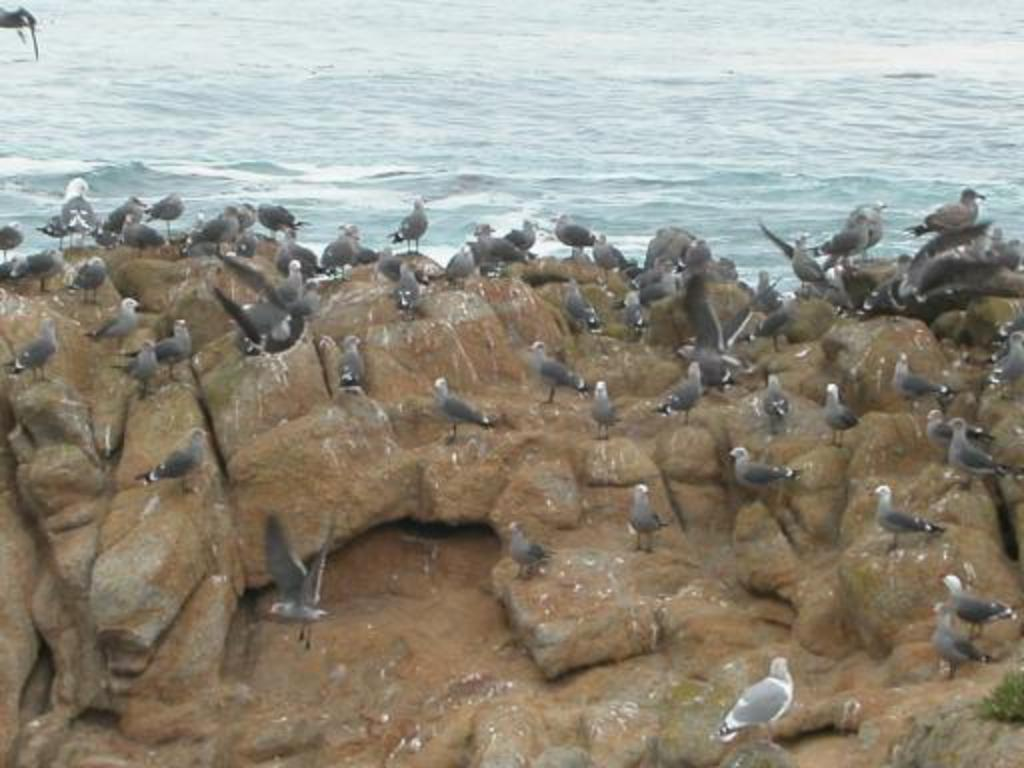What type of animals can be seen in the image? There are birds in the image. Where are the birds located? The birds are on a rock. What is the background of the image? The rock is in front of the sea. What songs are the birds singing in the image? There is no indication in the image that the birds are singing songs, so it cannot be determined from the picture. 